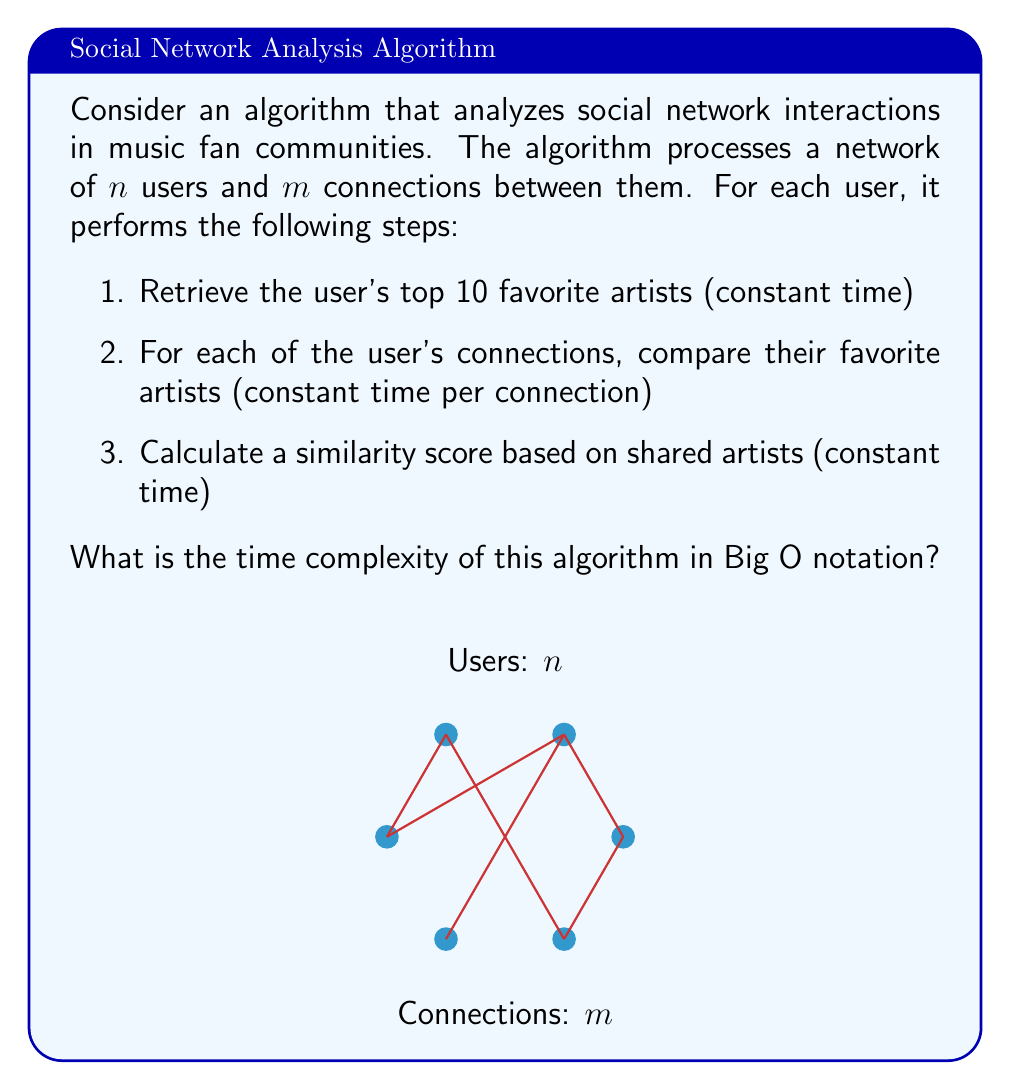Can you answer this question? Let's analyze the time complexity step by step:

1. The algorithm processes each user in the network. There are $n$ users, so this creates an outer loop of $n$ iterations.

2. For each user, we perform three operations:
   a. Retrieving top 10 favorite artists: This is done in constant time, $O(1)$.
   b. Comparing with each connection's favorite artists: This is done for each of the user's connections. In the worst case, a user could be connected to all other users, which would be $O(n)$. However, on average, each user is connected to $\frac{m}{n}$ other users (as there are $m$ total connections distributed among $n$ users).
   c. Calculating similarity score: This is done in constant time, $O(1)$.

3. The time complexity for processing one user is therefore:
   $O(1) + O(\frac{m}{n}) + O(1) = O(\frac{m}{n})$

4. As we do this for all $n$ users, the total time complexity is:
   $n * O(\frac{m}{n}) = O(m)$

5. Therefore, the overall time complexity of the algorithm is $O(m)$, where $m$ is the number of connections in the network.

This result makes intuitive sense: the algorithm's runtime is primarily determined by the number of connections it needs to analyze, rather than the number of users. In a sparse network where $m < n^2$, this is more efficient than the naive $O(n^2)$ approach of comparing every user with every other user.
Answer: $O(m)$ 